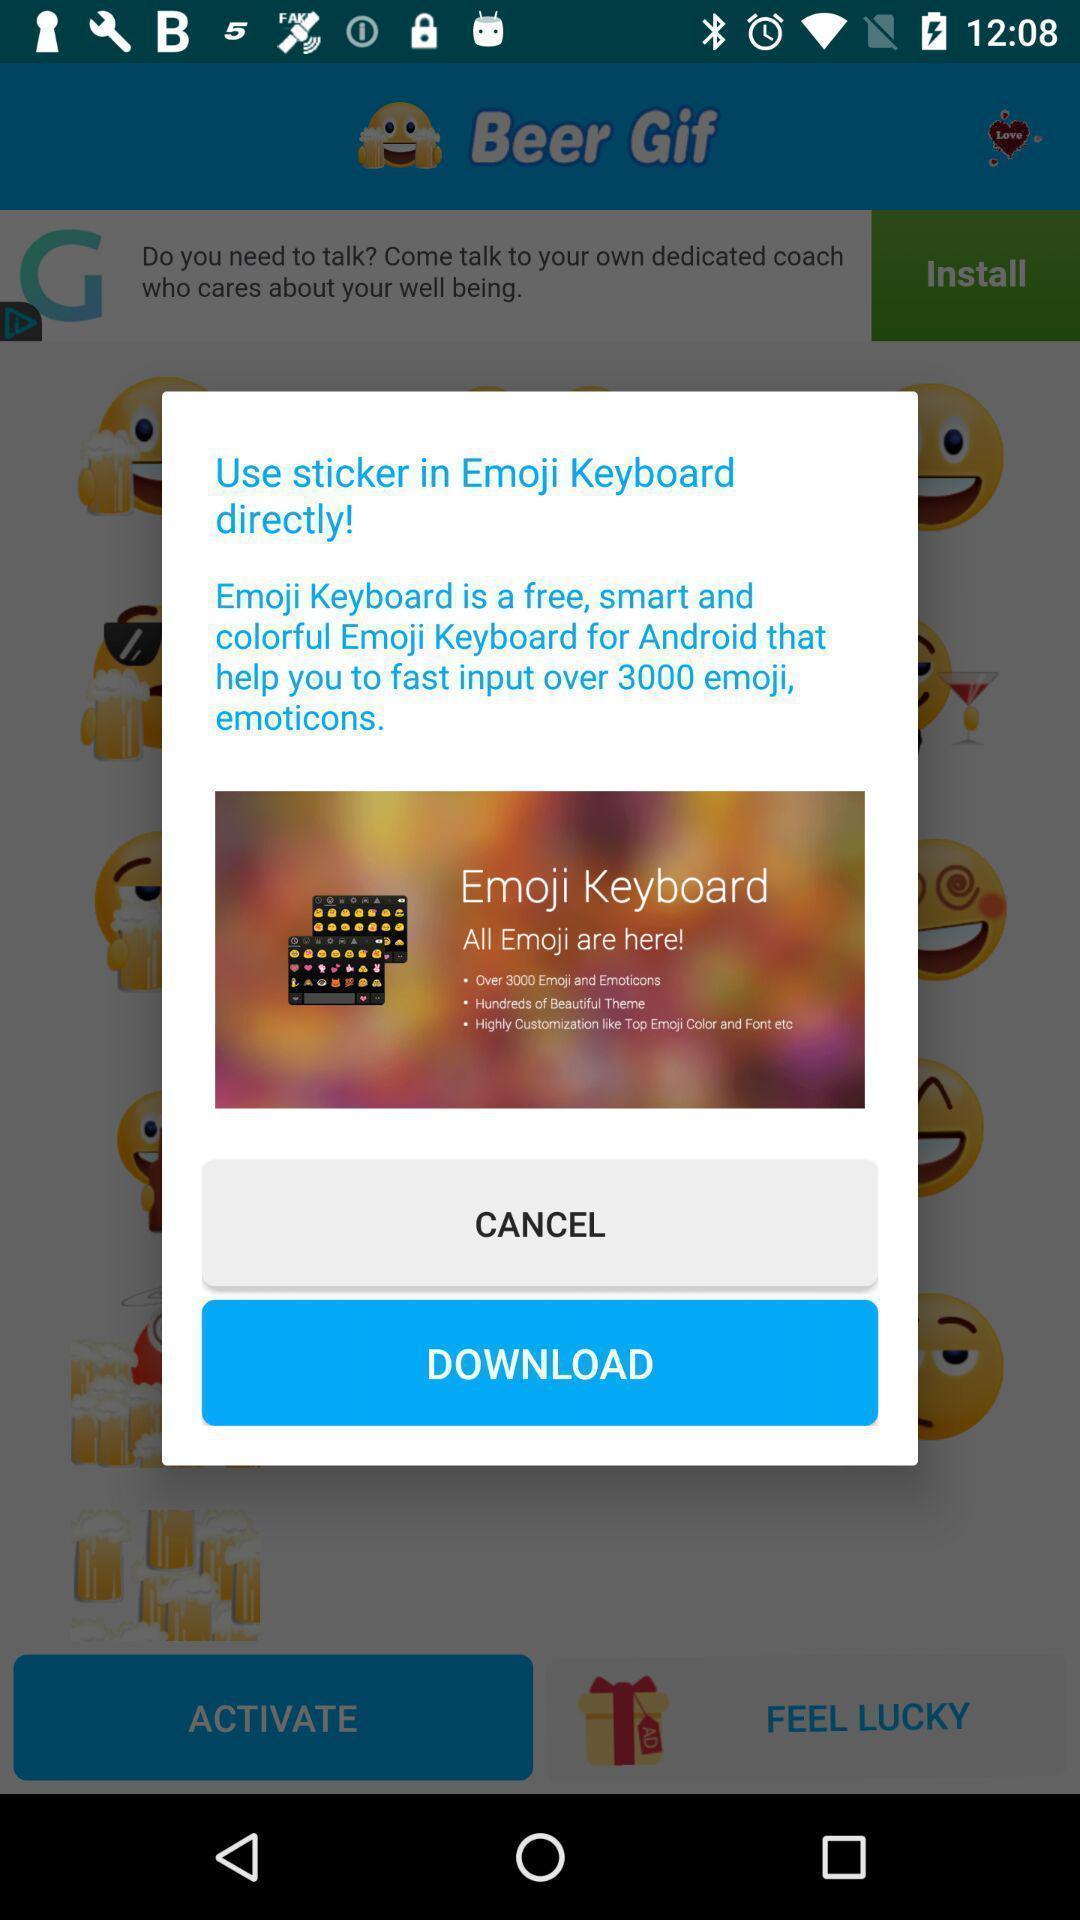What is the overall content of this screenshot? Pop-up asking to download a sticker in keyboard app. 